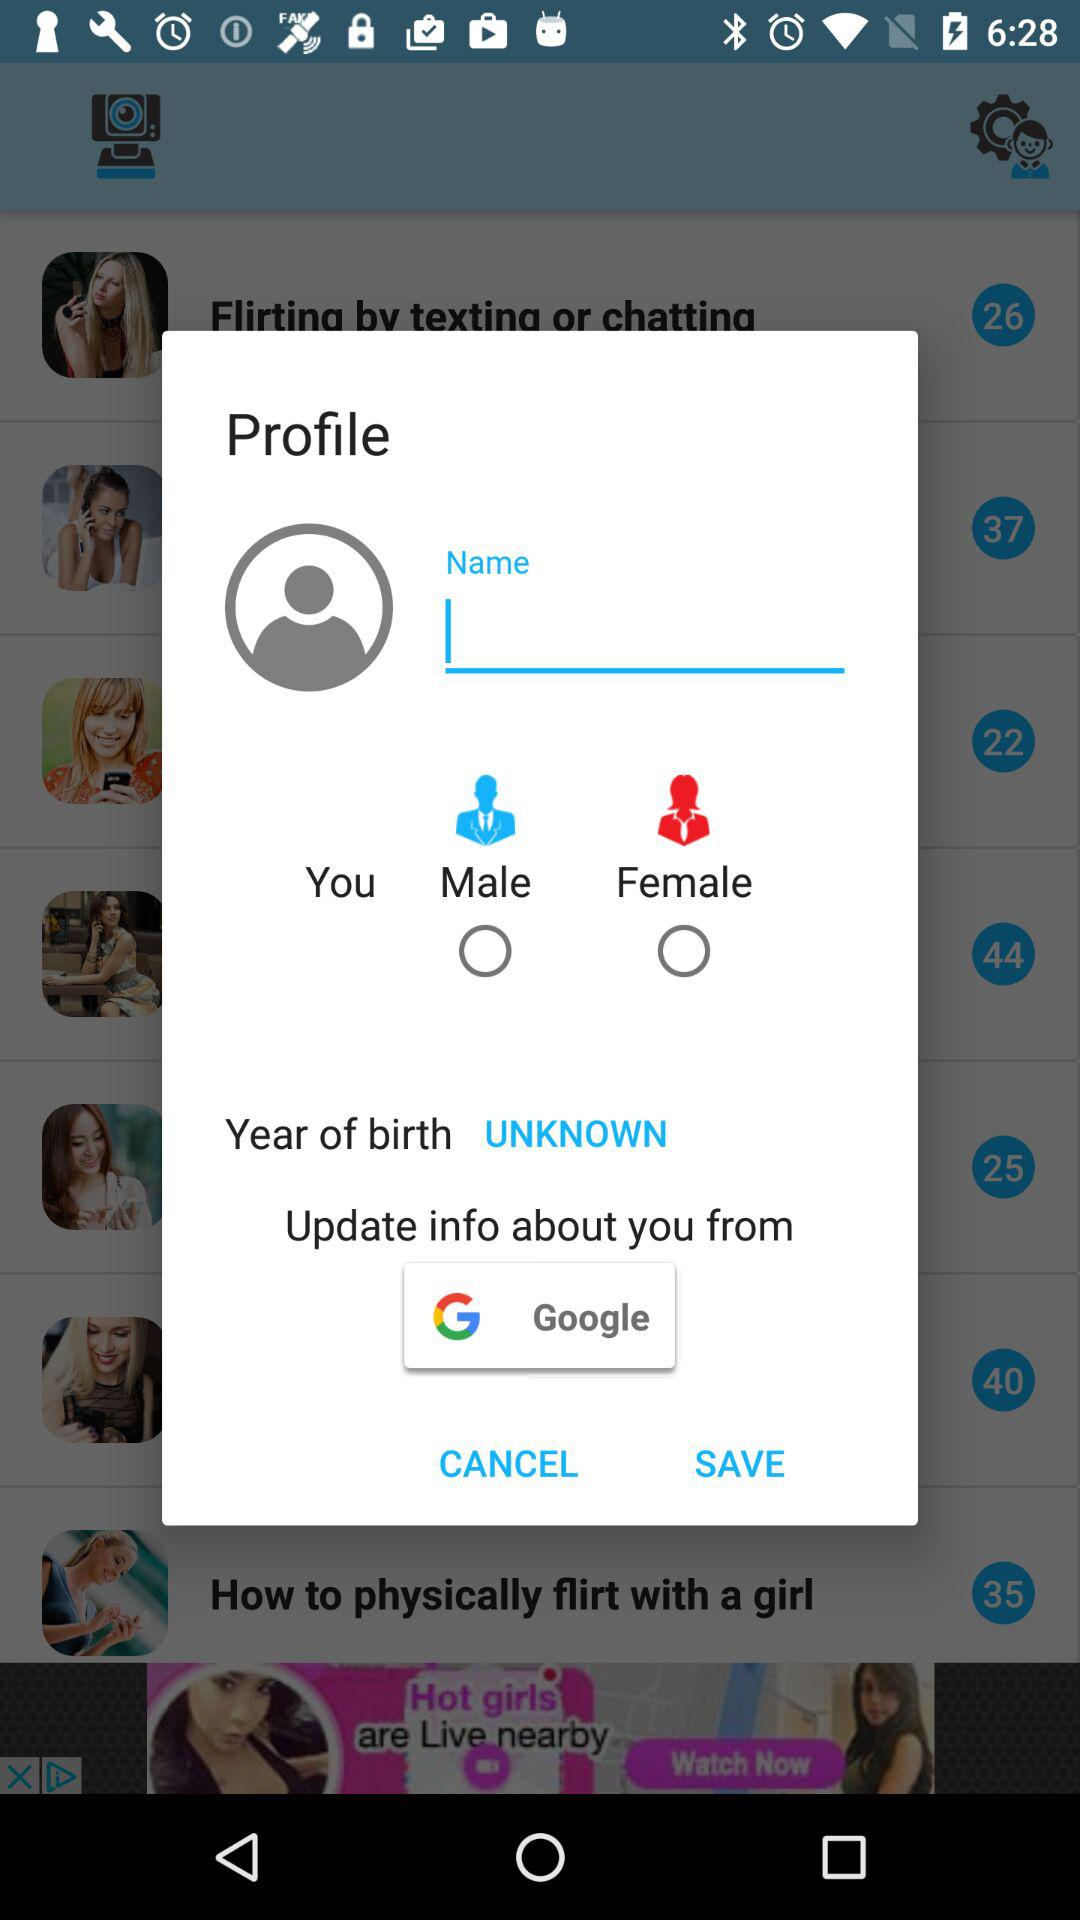From where can we update the info? You can update the info from "Google". 